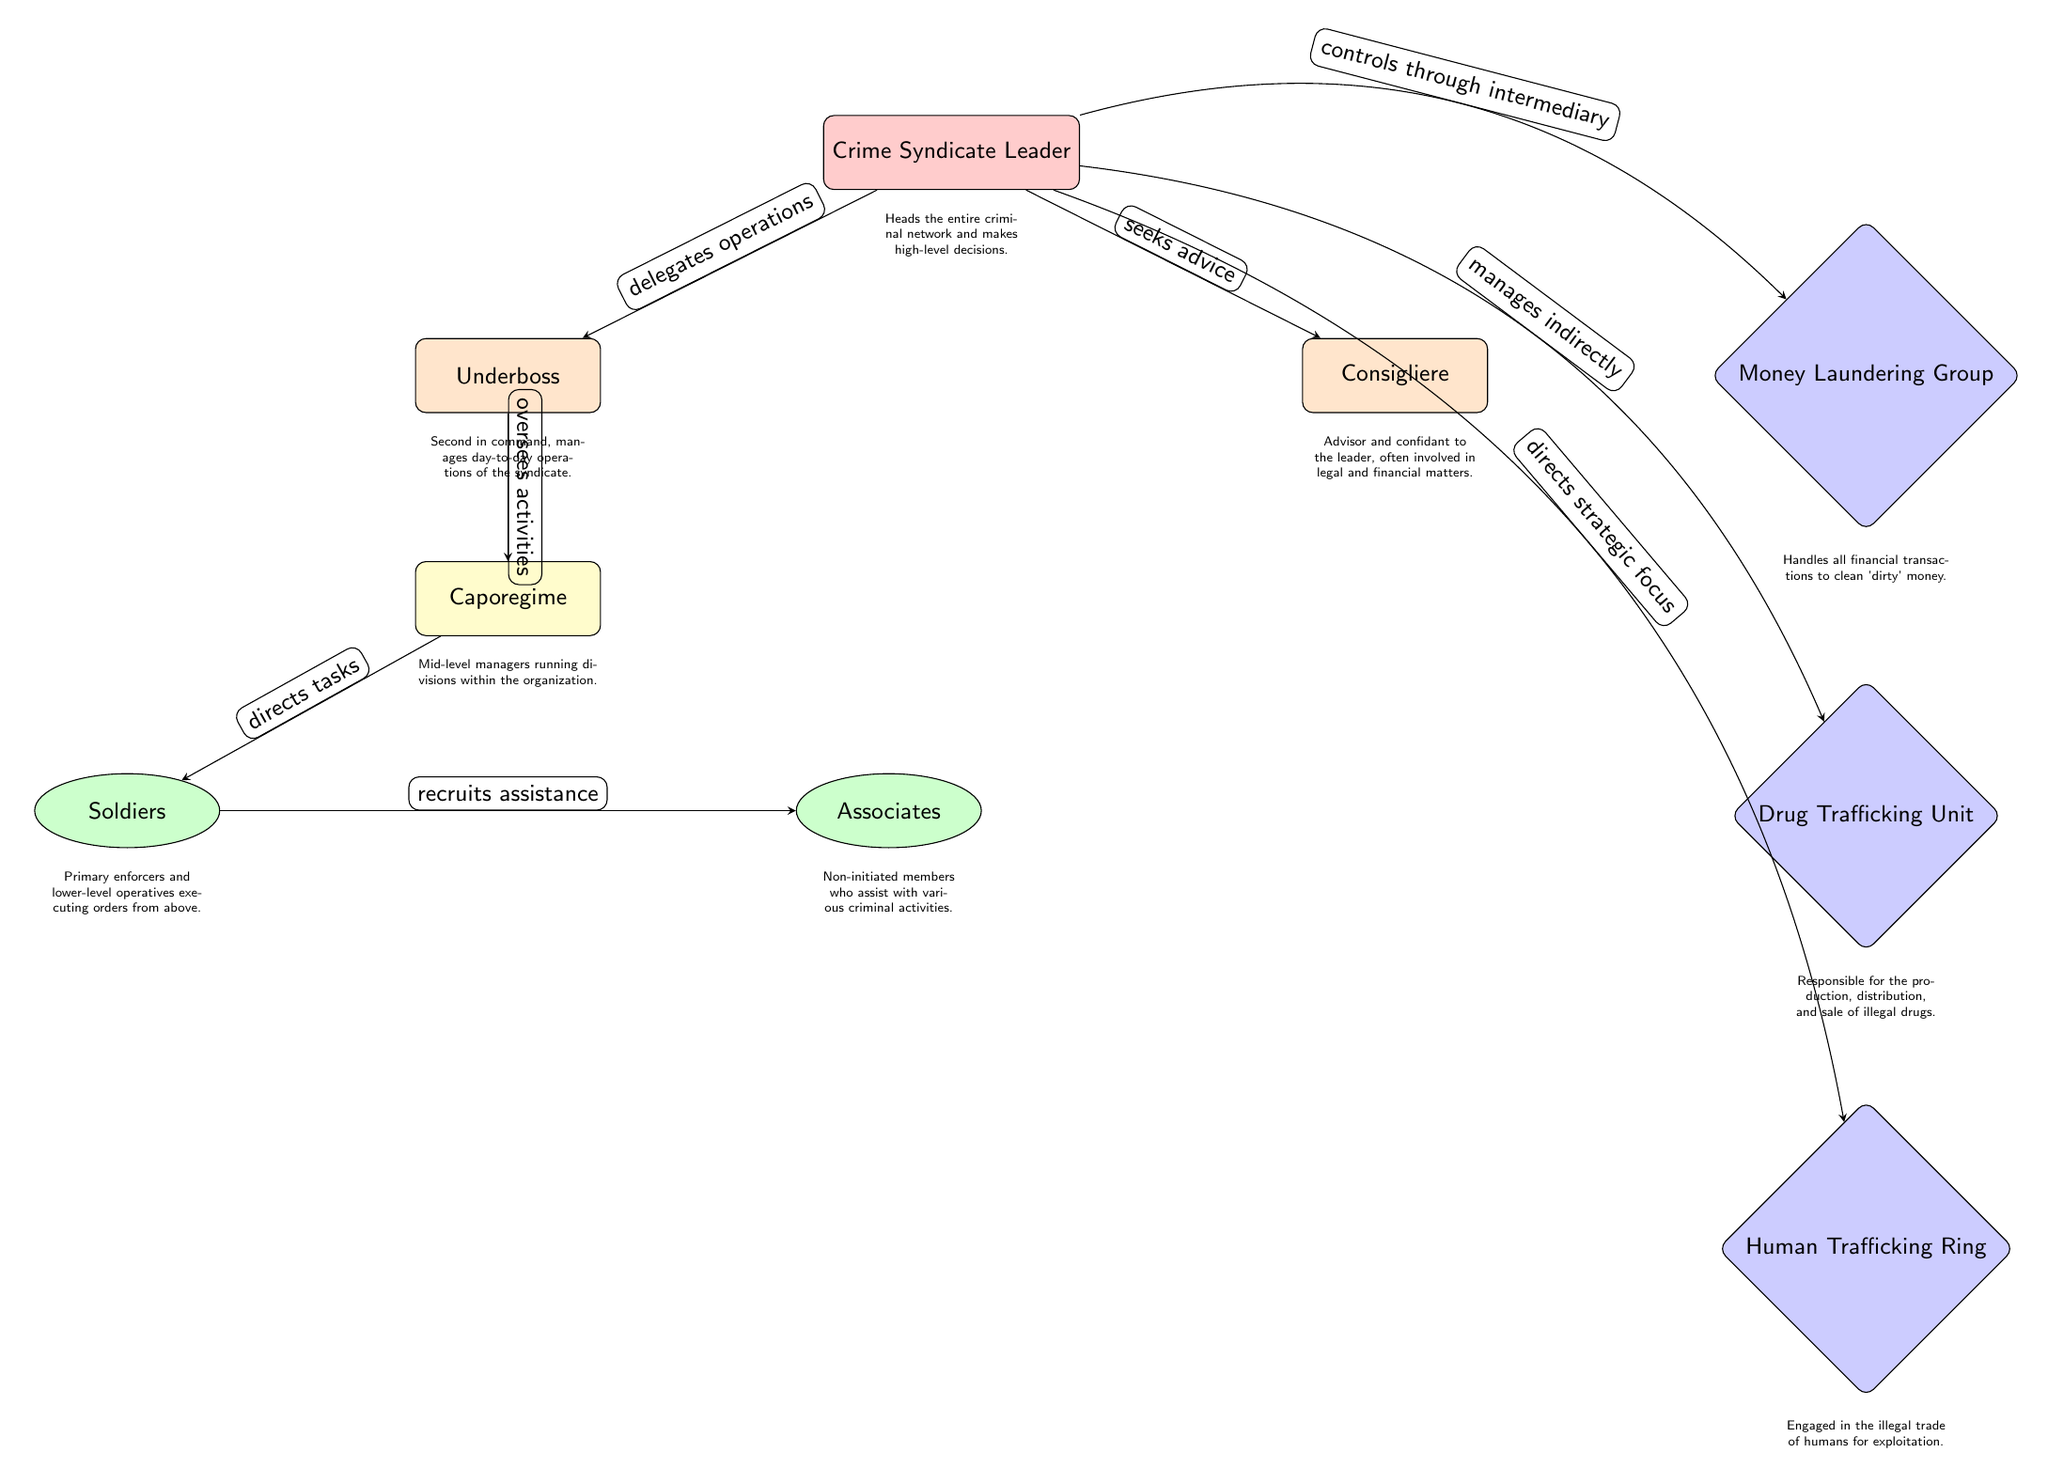What is the role of the node directly below the Crime Syndicate Leader? The node directly below the Crime Syndicate Leader is the Underboss, as indicated in the diagram layout.
Answer: Underboss How many primary operational units are connected to the leader? The diagram shows three main operational units that stem from the Crime Syndicate Leader: the Money Laundering Group, the Drug Trafficking Unit, and the Human Trafficking Ring.
Answer: 3 Who oversees activities of the Caporegime? The Caporegime is overseen by the Underboss, as shown in the diagram where the arrow indicates this relationship.
Answer: Underboss What is the primary responsibility of the Money Laundering Group? The Money Laundering Group is responsible for handling all financial transactions to clean 'dirty' money, as described in the node's definition.
Answer: Financial transactions Which two roles are considered lower-level operatives in the organization? The Soldiers and Associates are identified as lower-level operatives in the organization as per the structure depicted in the diagram.
Answer: Soldiers, Associates If the Crime Syndicate Leader delegates operations, who does he delegate to? The Crime Syndicate Leader delegates operations to the Underboss, as represented by the directed edge between these two nodes in the diagram.
Answer: Underboss What type of relationship exists between the Consigliere and the Crime Syndicate Leader? The relationship is one of seeking advice, as signified by the arrow that shows the flow of communication from the leader to the consigliere.
Answer: Seeks advice How does the Caporegime interact with the Soldiers? The Caporegime directs tasks to the Soldiers, as demonstrated by the directed arrow from Caporegime to Soldiers representing this interaction.
Answer: Directs tasks What color represents the roles involved in money laundering? The roles involved in money laundering are represented by the color blue in the diagram, specifically for the Money Laundering Group node.
Answer: Blue What is the lowest hierarchy in the depicted organization? The lowest hierarchy in the organization is occupied by the Associates, as they are positioned directly below the Soldiers in the hierarchy.
Answer: Associates 